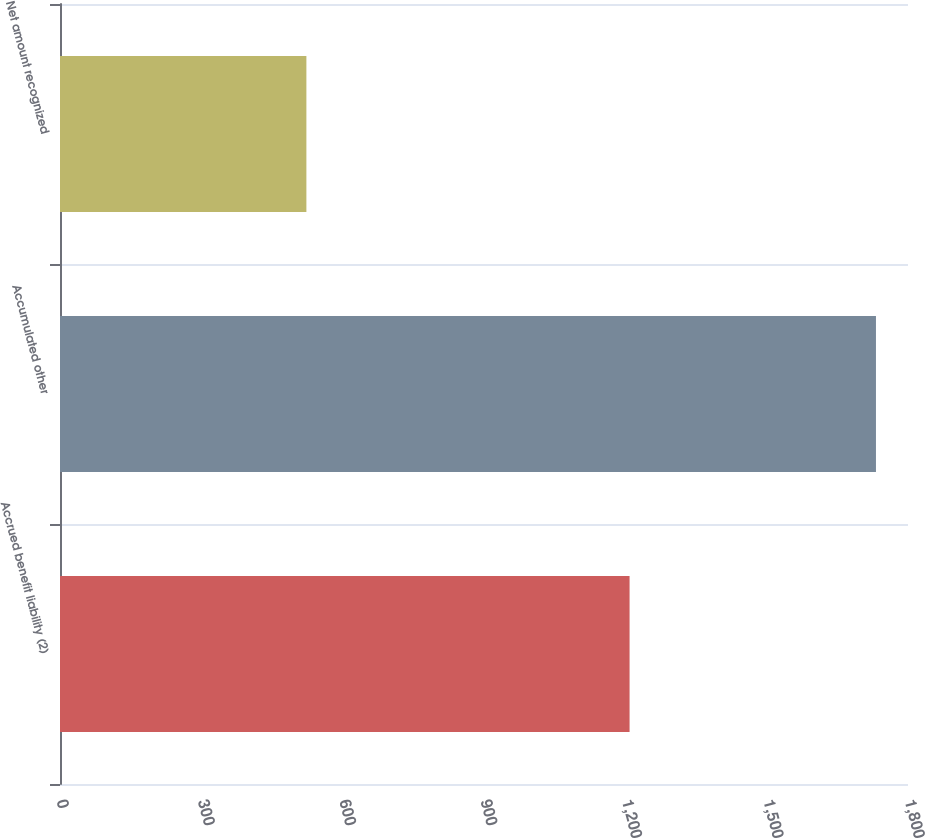<chart> <loc_0><loc_0><loc_500><loc_500><bar_chart><fcel>Accrued benefit liability (2)<fcel>Accumulated other<fcel>Net amount recognized<nl><fcel>1209<fcel>1732<fcel>523<nl></chart> 